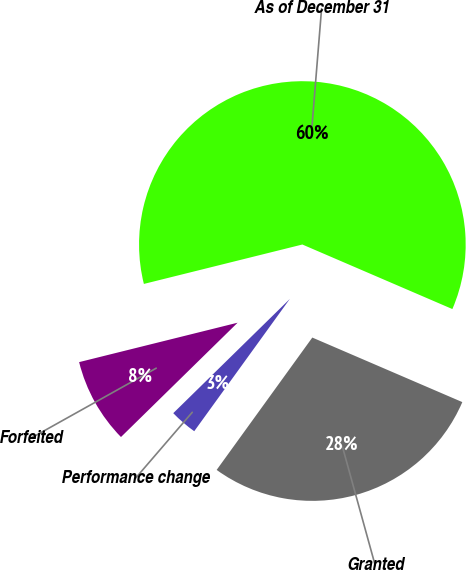<chart> <loc_0><loc_0><loc_500><loc_500><pie_chart><fcel>Granted<fcel>Performance change<fcel>Forfeited<fcel>As of December 31<nl><fcel>28.49%<fcel>2.7%<fcel>8.46%<fcel>60.34%<nl></chart> 